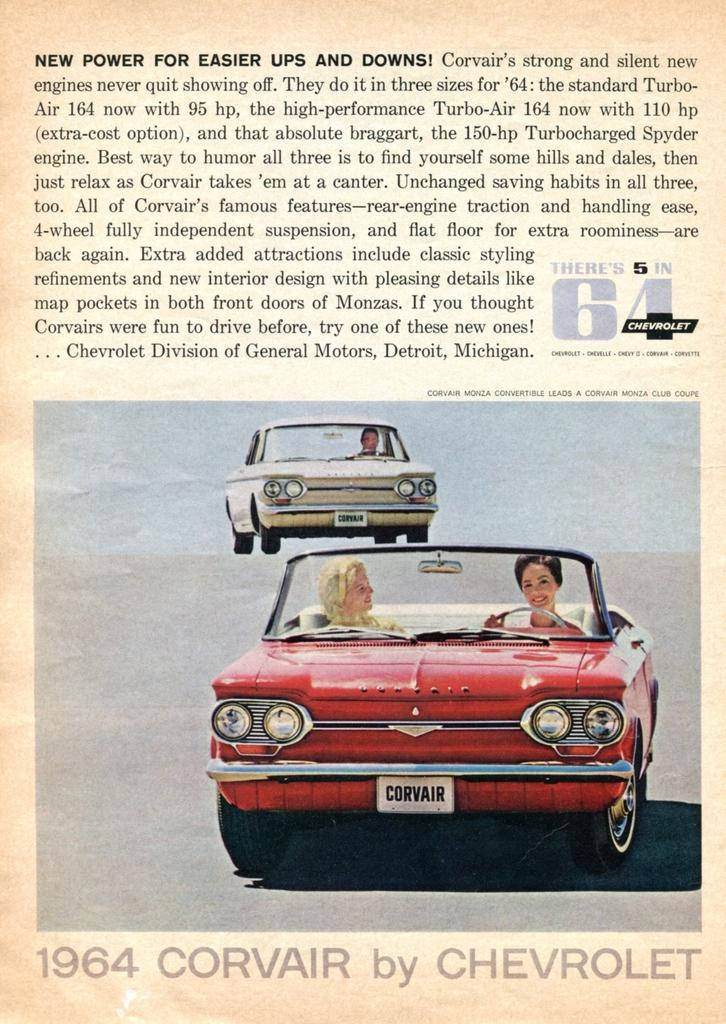What is the main subject of the poster in the image? The main subject of the poster in the image is two cars. Are there any people in the poster? Yes, there are people in the cars. What else can be seen on the poster besides the cars and people? There is text written on the poster. What is the secretary's role in the poster? There is no secretary present in the image or the poster. 